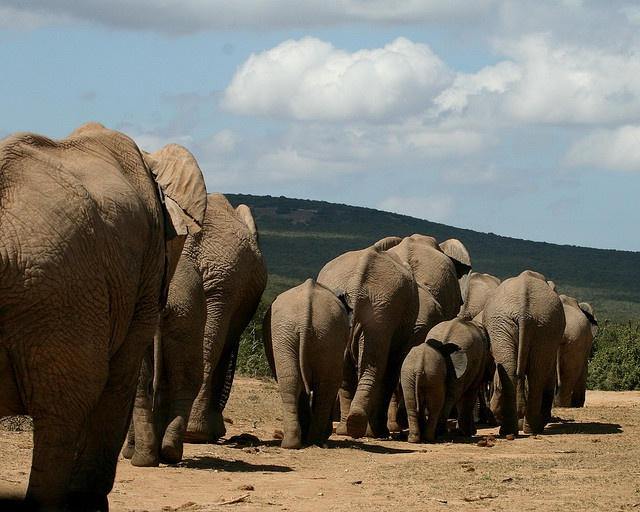Describe the objects in this image and their specific colors. I can see elephant in darkgray, black, tan, gray, and maroon tones, elephant in darkgray, black, tan, gray, and maroon tones, elephant in darkgray, black, gray, and tan tones, elephant in darkgray, black, gray, and tan tones, and elephant in darkgray, black, tan, gray, and maroon tones in this image. 